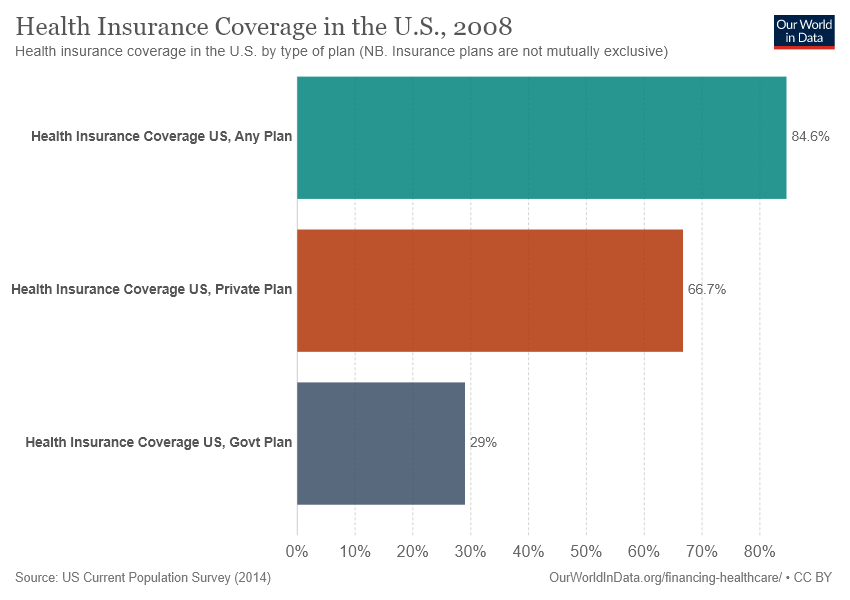Mention a couple of crucial points in this snapshot. The value of the smallest bar is 0.29. The sum of the smallest two bars is greater than the value of the largest bar. 